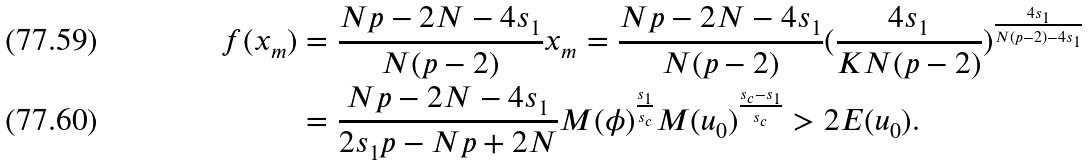<formula> <loc_0><loc_0><loc_500><loc_500>f ( x _ { m } ) & = \frac { N p - 2 N - 4 s _ { 1 } } { N ( p - 2 ) } x _ { m } = \frac { N p - 2 N - 4 s _ { 1 } } { N ( p - 2 ) } ( \frac { 4 s _ { 1 } } { K N ( p - 2 ) } ) ^ { \frac { 4 s _ { 1 } } { N ( p - 2 ) - 4 s _ { 1 } } } \\ & = \frac { N p - 2 N - 4 s _ { 1 } } { 2 s _ { 1 } p - N p + 2 N } M ( \phi ) ^ { \frac { s _ { 1 } } { s _ { c } } } M ( u _ { 0 } ) ^ { \frac { s _ { c } - s _ { 1 } } { s _ { c } } } > 2 E ( u _ { 0 } ) .</formula> 